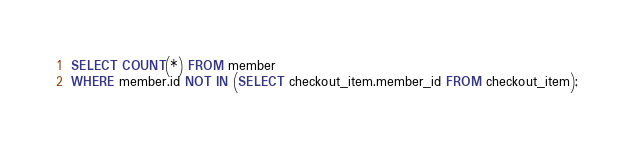Convert code to text. <code><loc_0><loc_0><loc_500><loc_500><_SQL_>SELECT COUNT(*) FROM member
WHERE member.id NOT IN (SELECT checkout_item.member_id FROM checkout_item);</code> 